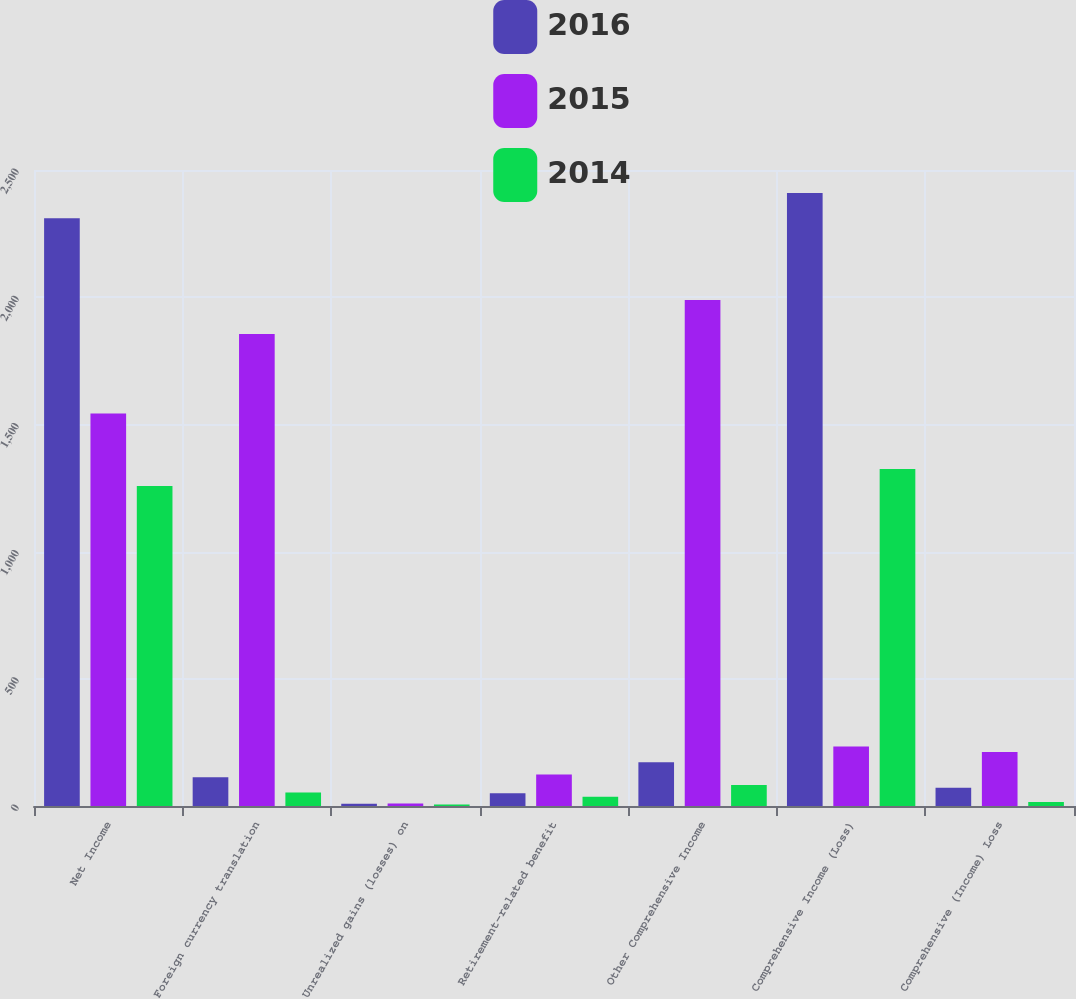Convert chart. <chart><loc_0><loc_0><loc_500><loc_500><stacked_bar_chart><ecel><fcel>Net Income<fcel>Foreign currency translation<fcel>Unrealized gains (losses) on<fcel>Retirement-related benefit<fcel>Other Comprehensive Income<fcel>Comprehensive Income (Loss)<fcel>Comprehensive (Income) Loss<nl><fcel>2016<fcel>2310<fcel>113<fcel>9<fcel>50<fcel>172<fcel>2410<fcel>72<nl><fcel>2015<fcel>1543<fcel>1855<fcel>10<fcel>124<fcel>1989<fcel>234<fcel>212<nl><fcel>2014<fcel>1258<fcel>53<fcel>6<fcel>36<fcel>83<fcel>1325<fcel>16<nl></chart> 